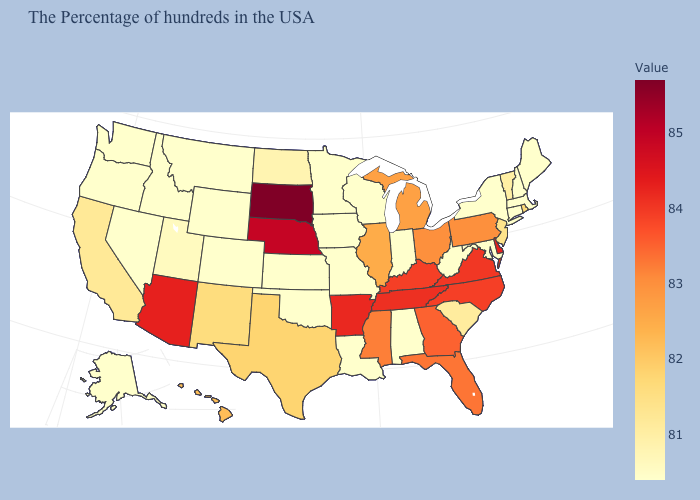Among the states that border Missouri , does Oklahoma have the lowest value?
Give a very brief answer. Yes. Does New Jersey have the lowest value in the USA?
Give a very brief answer. No. Is the legend a continuous bar?
Keep it brief. Yes. Does Pennsylvania have the highest value in the Northeast?
Keep it brief. Yes. Among the states that border Washington , which have the highest value?
Short answer required. Idaho, Oregon. Among the states that border Idaho , does Utah have the highest value?
Concise answer only. Yes. 